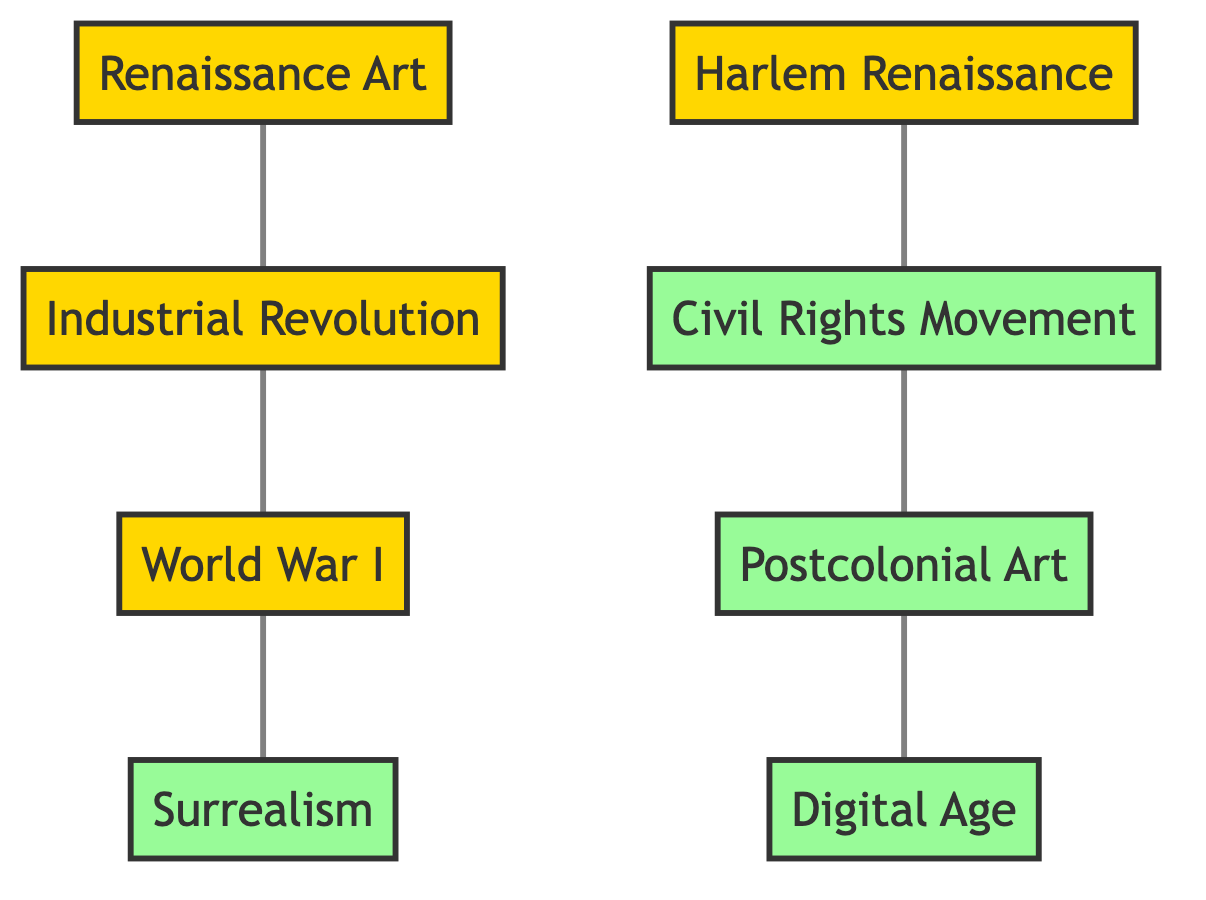What are the total number of nodes in the diagram? The diagram contains a list of nodes, which can be counted directly. There are 8 unique nodes listed: Renaissance Art, Industrial Revolution, World War I, Harlem Renaissance, Surrealism, Civil Rights Movement, Postcolonial Art, and Digital Age.
Answer: 8 Which two historical events are directly connected to the Industrial Revolution? The Industrial Revolution is connected to two nodes in the diagram: Renaissance Art and World War I, as indicated by the edges connecting these nodes.
Answer: Renaissance Art and World War I What is the immediate successor of World War I in the graph? Following the edges from World War I, the direct connection leads to Surrealism. The flow of the diagram shows that Surrealism is the node that comes after World War I.
Answer: Surrealism How many edges are there connecting the nodes? The edges in the diagram define the connections between the nodes. Counting the listed edges shows there are a total of 6 connections made.
Answer: 6 Which movement follows the Civil Rights Movement in the diagram? By examining the edge connections, the next connected node after the Civil Rights Movement is Postcolonial Art, demonstrating the sequence of influences on artistic practices.
Answer: Postcolonial Art What is the relationship between Harlem Renaissance and Civil Rights Movement? The relationship is a direct connection where Harlem Renaissance is linked to Civil Rights Movement via an edge. This shows the influence of the Harlem Renaissance on the Civil Rights movement.
Answer: Directly connected Identify the first event in the chronological flow of the diagram. The first node in the flow is Renaissance Art, as it connects to the Industrial Revolution and sets the stage for the subsequent events, indicating its position as the earliest event represented in the diagram.
Answer: Renaissance Art How many modern art movements are represented in the diagram? The diagram shows 4 modern art movements, which are Surrealism, Civil Rights Movement, Postcolonial Art, and Digital Age, indicating a clear classification of contemporary influences.
Answer: 4 What is the last node in the flow of the diagram? Postcolonial Art directly connects to Digital Age as the terminal point of the connections, making it the last artistic movement represented in the sequence.
Answer: Digital Age 